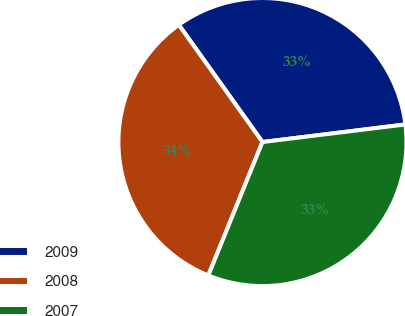<chart> <loc_0><loc_0><loc_500><loc_500><pie_chart><fcel>2009<fcel>2008<fcel>2007<nl><fcel>32.91%<fcel>34.0%<fcel>33.08%<nl></chart> 